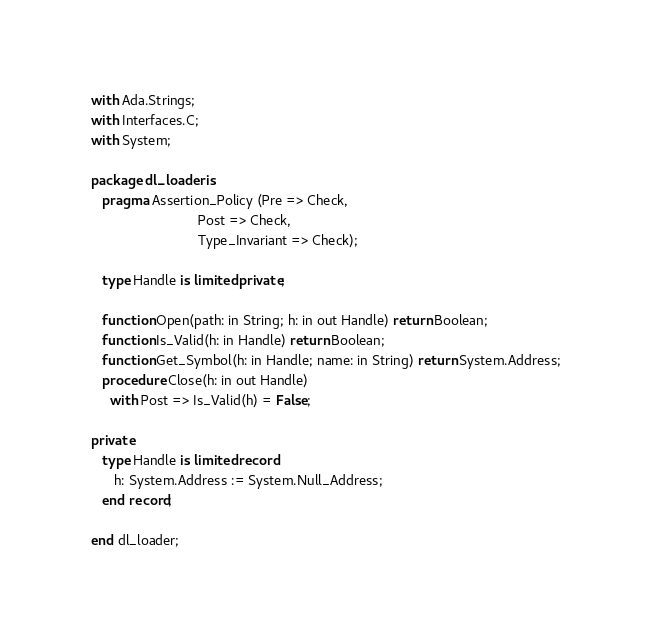Convert code to text. <code><loc_0><loc_0><loc_500><loc_500><_Ada_>with Ada.Strings;
with Interfaces.C;
with System;

package dl_loader is
   pragma Assertion_Policy (Pre => Check,
                            Post => Check,
                            Type_Invariant => Check);

   type Handle is limited private;

   function Open(path: in String; h: in out Handle) return Boolean;
   function Is_Valid(h: in Handle) return Boolean;
   function Get_Symbol(h: in Handle; name: in String) return System.Address;
   procedure Close(h: in out Handle)
     with Post => Is_Valid(h) = False;

private
   type Handle is limited record
      h: System.Address := System.Null_Address;
   end record;

end dl_loader;
</code> 